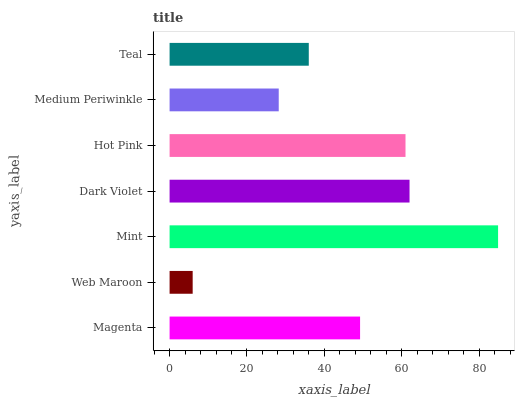Is Web Maroon the minimum?
Answer yes or no. Yes. Is Mint the maximum?
Answer yes or no. Yes. Is Mint the minimum?
Answer yes or no. No. Is Web Maroon the maximum?
Answer yes or no. No. Is Mint greater than Web Maroon?
Answer yes or no. Yes. Is Web Maroon less than Mint?
Answer yes or no. Yes. Is Web Maroon greater than Mint?
Answer yes or no. No. Is Mint less than Web Maroon?
Answer yes or no. No. Is Magenta the high median?
Answer yes or no. Yes. Is Magenta the low median?
Answer yes or no. Yes. Is Web Maroon the high median?
Answer yes or no. No. Is Medium Periwinkle the low median?
Answer yes or no. No. 